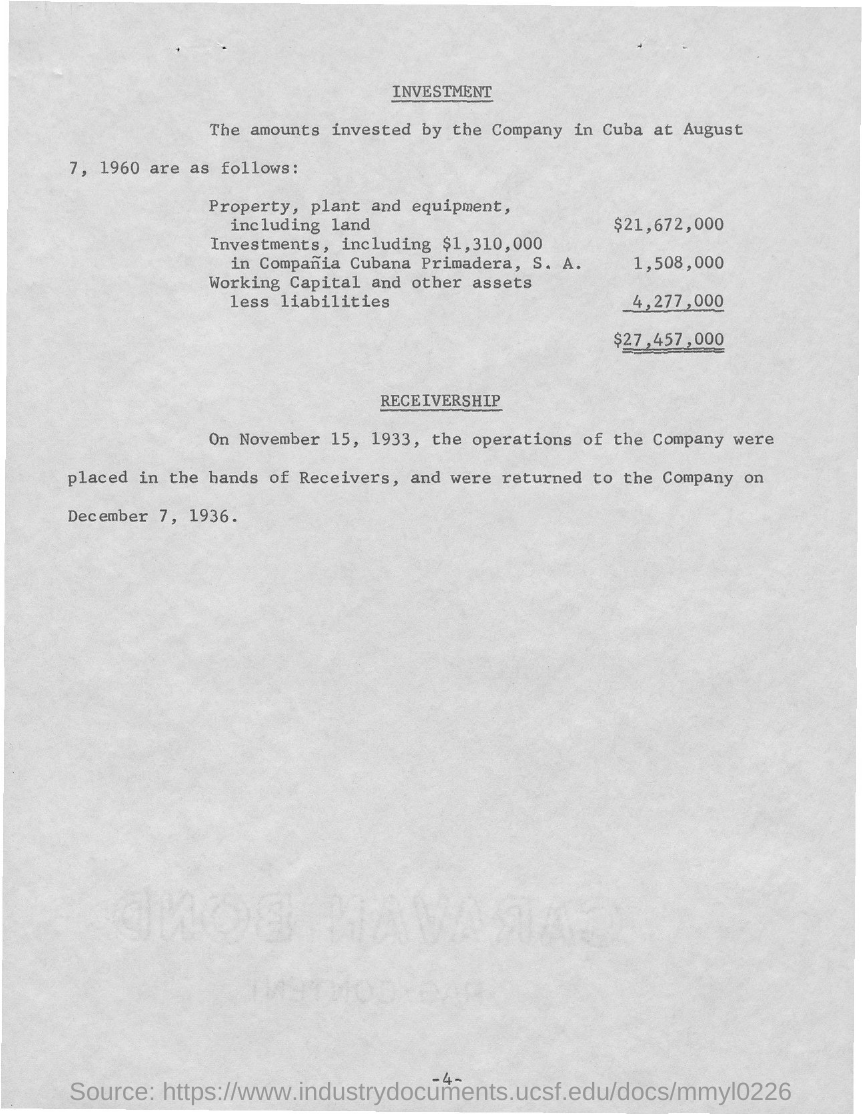Point out several critical features in this image. The first title in the document is 'Investment'. The second title in this document is "Receivership. 